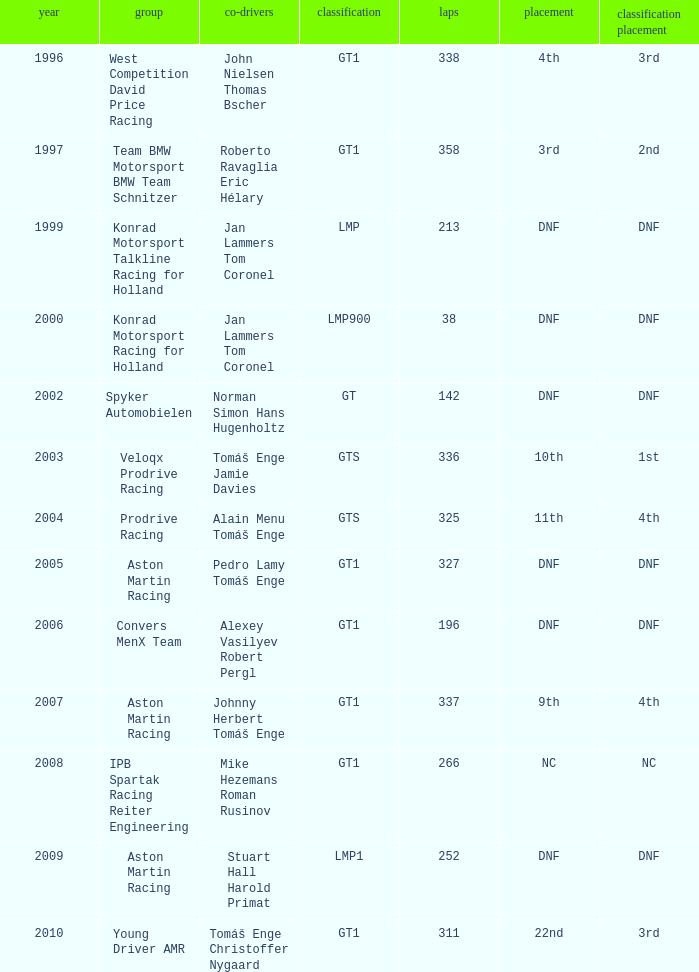What was the position in 1997? 3rd. Help me parse the entirety of this table. {'header': ['year', 'group', 'co-drivers', 'classification', 'laps', 'placement', 'classification placement'], 'rows': [['1996', 'West Competition David Price Racing', 'John Nielsen Thomas Bscher', 'GT1', '338', '4th', '3rd'], ['1997', 'Team BMW Motorsport BMW Team Schnitzer', 'Roberto Ravaglia Eric Hélary', 'GT1', '358', '3rd', '2nd'], ['1999', 'Konrad Motorsport Talkline Racing for Holland', 'Jan Lammers Tom Coronel', 'LMP', '213', 'DNF', 'DNF'], ['2000', 'Konrad Motorsport Racing for Holland', 'Jan Lammers Tom Coronel', 'LMP900', '38', 'DNF', 'DNF'], ['2002', 'Spyker Automobielen', 'Norman Simon Hans Hugenholtz', 'GT', '142', 'DNF', 'DNF'], ['2003', 'Veloqx Prodrive Racing', 'Tomáš Enge Jamie Davies', 'GTS', '336', '10th', '1st'], ['2004', 'Prodrive Racing', 'Alain Menu Tomáš Enge', 'GTS', '325', '11th', '4th'], ['2005', 'Aston Martin Racing', 'Pedro Lamy Tomáš Enge', 'GT1', '327', 'DNF', 'DNF'], ['2006', 'Convers MenX Team', 'Alexey Vasilyev Robert Pergl', 'GT1', '196', 'DNF', 'DNF'], ['2007', 'Aston Martin Racing', 'Johnny Herbert Tomáš Enge', 'GT1', '337', '9th', '4th'], ['2008', 'IPB Spartak Racing Reiter Engineering', 'Mike Hezemans Roman Rusinov', 'GT1', '266', 'NC', 'NC'], ['2009', 'Aston Martin Racing', 'Stuart Hall Harold Primat', 'LMP1', '252', 'DNF', 'DNF'], ['2010', 'Young Driver AMR', 'Tomáš Enge Christoffer Nygaard', 'GT1', '311', '22nd', '3rd']]} 